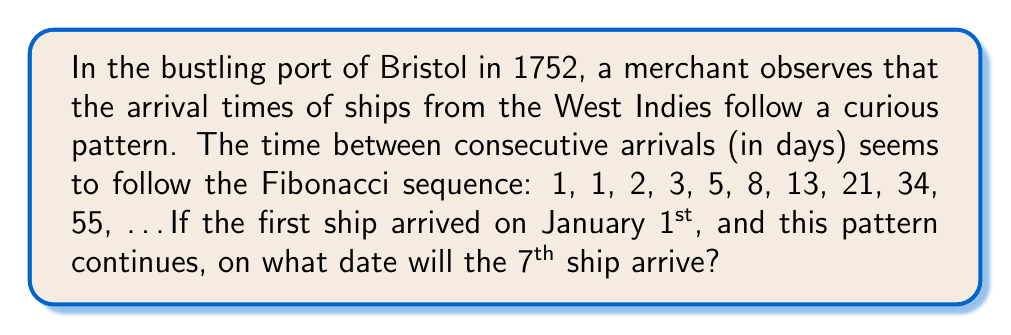Solve this math problem. Let's approach this step-by-step:

1) First, recall the Fibonacci sequence: Each number is the sum of the two preceding ones.
   $F_n = F_{n-1} + F_{n-2}$, where $F_1 = F_2 = 1$

2) We need to find the sum of the first 6 terms of the sequence, as this will give us the number of days until the 7th ship arrives.

3) Let's list out the first 6 terms and their sums:
   $F_1 = 1$
   $F_2 = 1$
   $F_3 = 2$
   $F_4 = 3$
   $F_5 = 5$
   $F_6 = 8$

4) Now, let's sum these terms:
   $S = F_1 + F_2 + F_3 + F_4 + F_5 + F_6$
   $S = 1 + 1 + 2 + 3 + 5 + 8 = 20$

5) So, the 7th ship will arrive 20 days after January 1st, 1752.

6) To find the date, we need to count 20 days from January 1st. Remember that 1752 was a leap year in the British Empire.

7) Counting 20 days from January 1st brings us to January 21st, 1752.
Answer: January 21st, 1752 